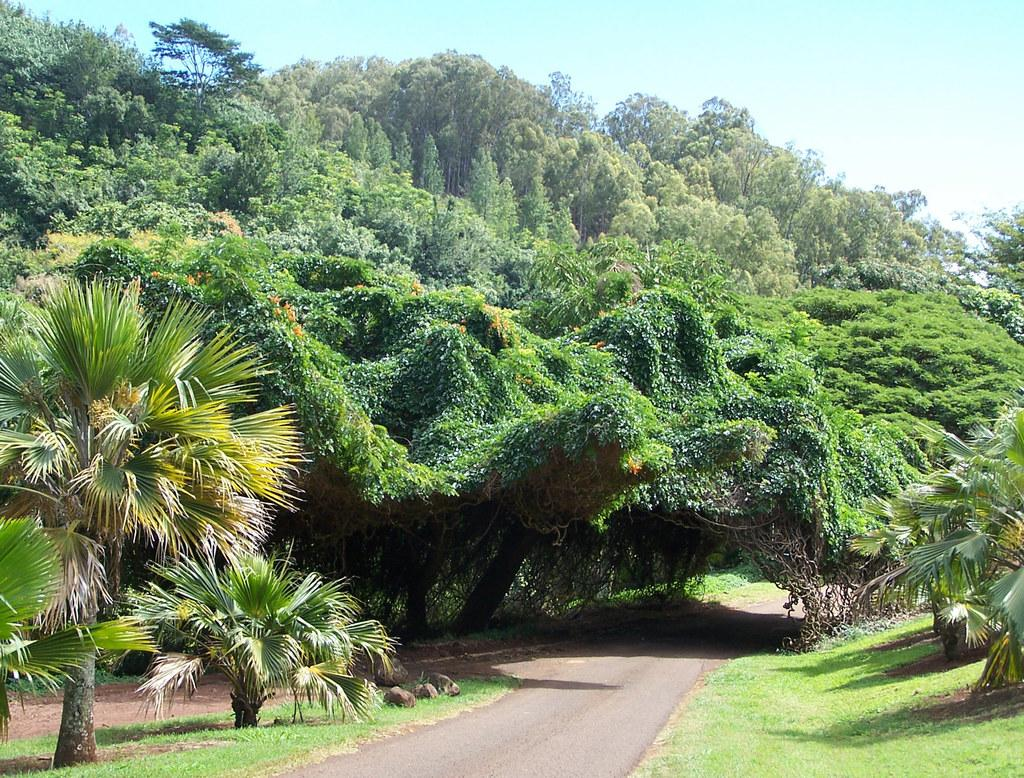What type of terrain is visible in the image? The ground is visible in the image, which includes rocks, grass, plants, and trees. Can you describe the vegetation in the image? There is grass, plants, and trees visible in the image. What part of the natural environment is visible in the image? The sky is visible in the image, in addition to the ground and vegetation. What type of machine is being used to extract quartz from the ground in the image? There is no machine or quartz present in the image; it features natural elements such as rocks, grass, plants, trees, and the sky. 